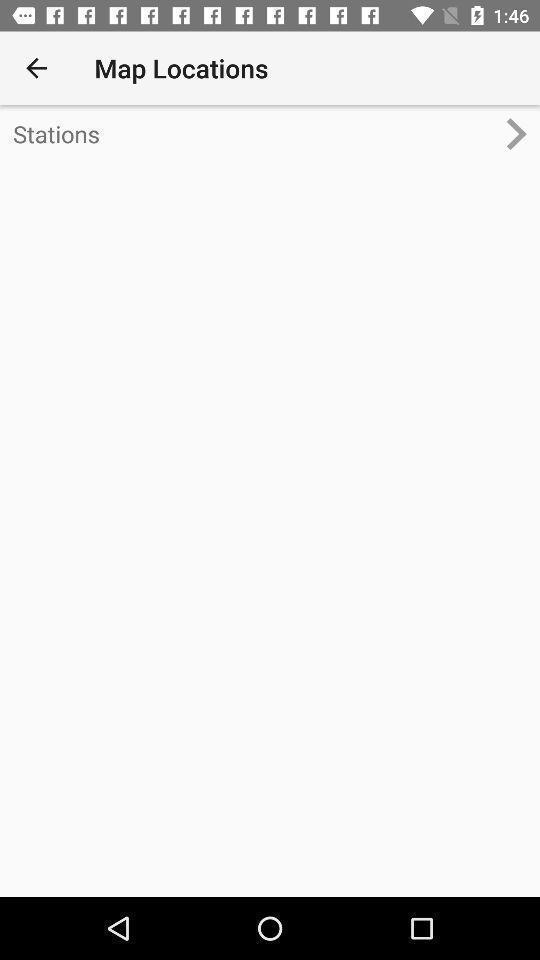What details can you identify in this image? Window displaying for routing locations. 